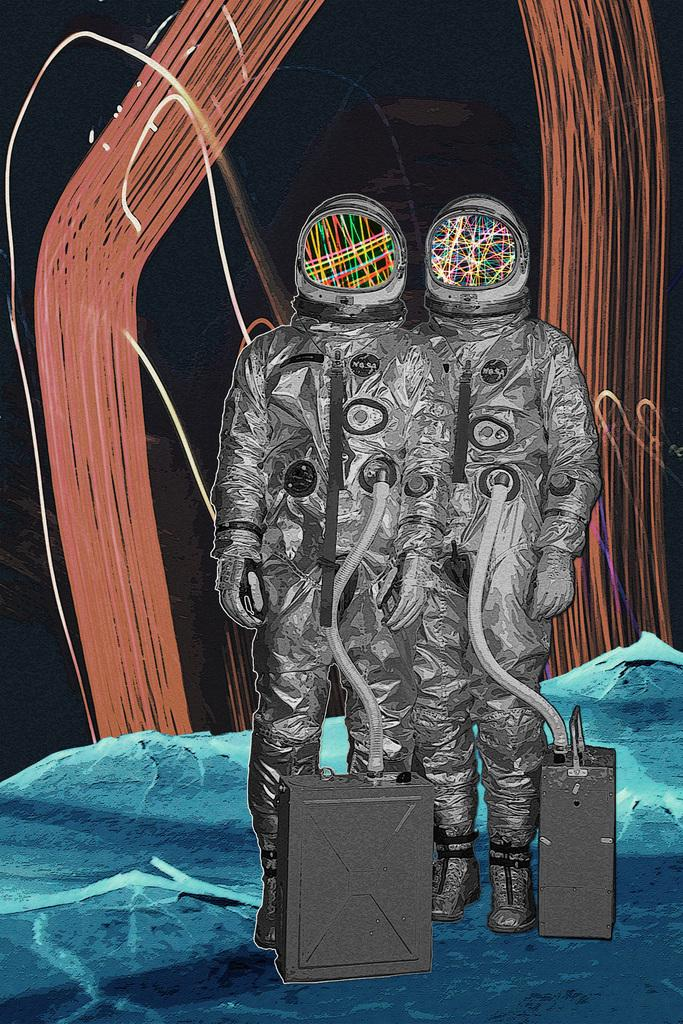What type of image is being described? The image is an edited image. How many people are in the image? There are two persons in the image. What are the people wearing? Both persons are wearing gold-colored dresses. What objects can be seen on the floor in the image? There are two boxes on the floor in the image. What type of discussion is taking place between the two persons in the image? There is no discussion taking place in the image; it only shows two persons wearing gold-colored dresses and two boxes on the floor. What nation are the two persons in the image from? The image does not provide any information about the nationality or origin of the two persons. 